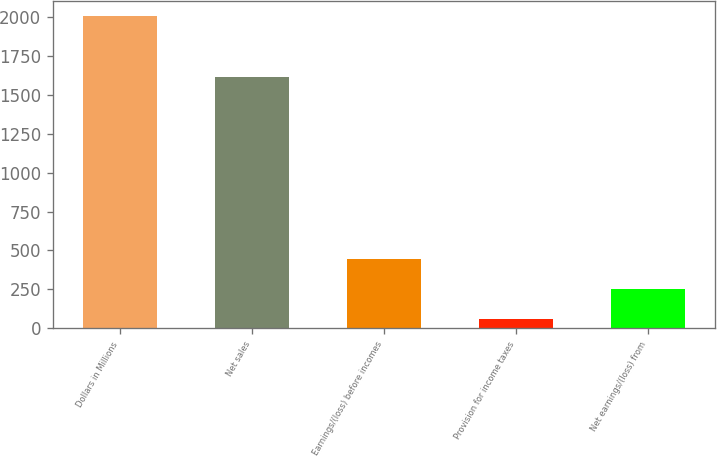Convert chart. <chart><loc_0><loc_0><loc_500><loc_500><bar_chart><fcel>Dollars in Millions<fcel>Net sales<fcel>Earnings/(loss) before incomes<fcel>Provision for income taxes<fcel>Net earnings/(loss) from<nl><fcel>2005<fcel>1617<fcel>448.2<fcel>59<fcel>253.6<nl></chart> 